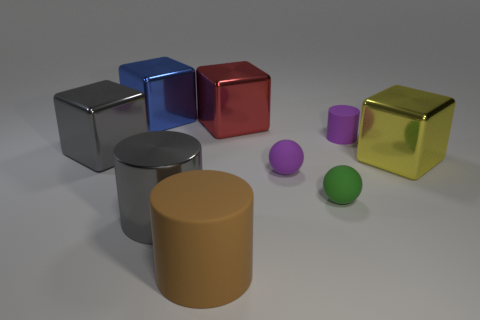Subtract all big brown cylinders. How many cylinders are left? 2 Add 1 gray things. How many objects exist? 10 Subtract all yellow cubes. How many cubes are left? 3 Subtract all balls. How many objects are left? 7 Subtract 3 blocks. How many blocks are left? 1 Subtract all big blue shiny cubes. Subtract all big metal blocks. How many objects are left? 4 Add 9 big yellow cubes. How many big yellow cubes are left? 10 Add 6 large shiny blocks. How many large shiny blocks exist? 10 Subtract 1 red blocks. How many objects are left? 8 Subtract all purple cylinders. Subtract all cyan spheres. How many cylinders are left? 2 